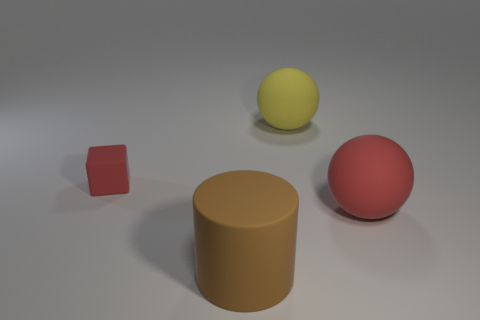There is a red matte object on the right side of the large yellow ball; how many matte balls are on the left side of it? On the left side of the large yellow ball, there are no matte balls. There is one cylindrical matte object, colored brown. 